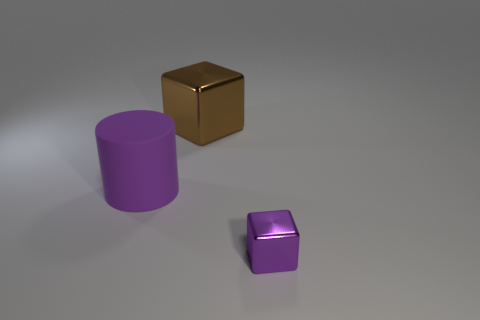Subtract 1 blocks. How many blocks are left? 1 Add 1 green objects. How many objects exist? 4 Add 1 cubes. How many cubes exist? 3 Subtract 0 blue cylinders. How many objects are left? 3 Subtract all cubes. How many objects are left? 1 Subtract all purple cubes. Subtract all red cylinders. How many cubes are left? 1 Subtract all brown metal things. Subtract all green spheres. How many objects are left? 2 Add 1 large brown metallic things. How many large brown metallic things are left? 2 